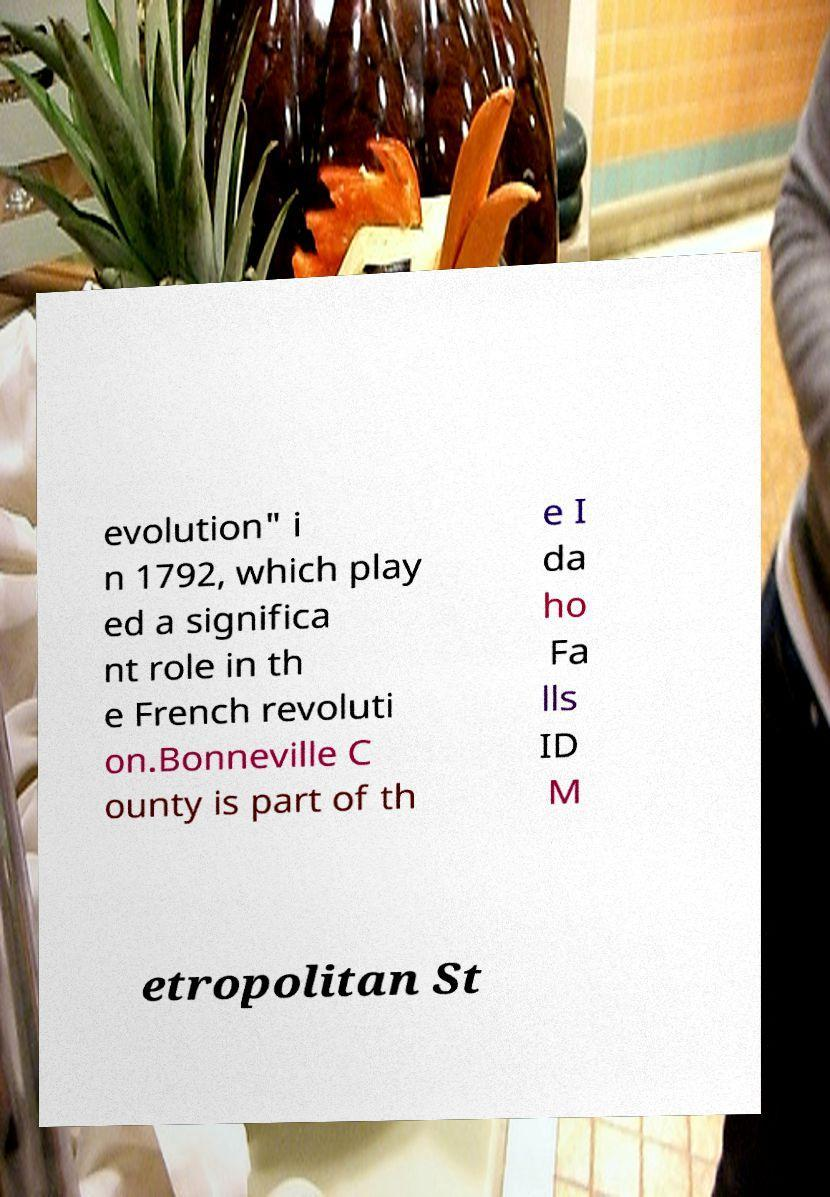Could you assist in decoding the text presented in this image and type it out clearly? evolution" i n 1792, which play ed a significa nt role in th e French revoluti on.Bonneville C ounty is part of th e I da ho Fa lls ID M etropolitan St 